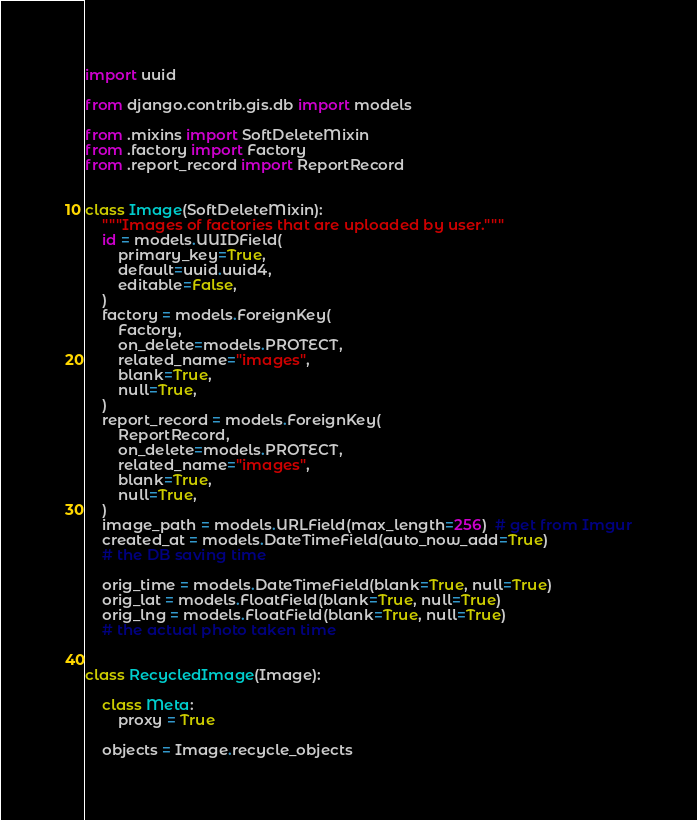<code> <loc_0><loc_0><loc_500><loc_500><_Python_>import uuid

from django.contrib.gis.db import models

from .mixins import SoftDeleteMixin
from .factory import Factory
from .report_record import ReportRecord


class Image(SoftDeleteMixin):
    """Images of factories that are uploaded by user."""
    id = models.UUIDField(
        primary_key=True,
        default=uuid.uuid4,
        editable=False,
    )
    factory = models.ForeignKey(
        Factory,
        on_delete=models.PROTECT,
        related_name="images",
        blank=True,
        null=True,
    )
    report_record = models.ForeignKey(
        ReportRecord,
        on_delete=models.PROTECT,
        related_name="images",
        blank=True,
        null=True,
    )
    image_path = models.URLField(max_length=256)  # get from Imgur
    created_at = models.DateTimeField(auto_now_add=True)
    # the DB saving time

    orig_time = models.DateTimeField(blank=True, null=True)
    orig_lat = models.FloatField(blank=True, null=True)
    orig_lng = models.FloatField(blank=True, null=True)
    # the actual photo taken time


class RecycledImage(Image):

    class Meta:
        proxy = True

    objects = Image.recycle_objects
</code> 